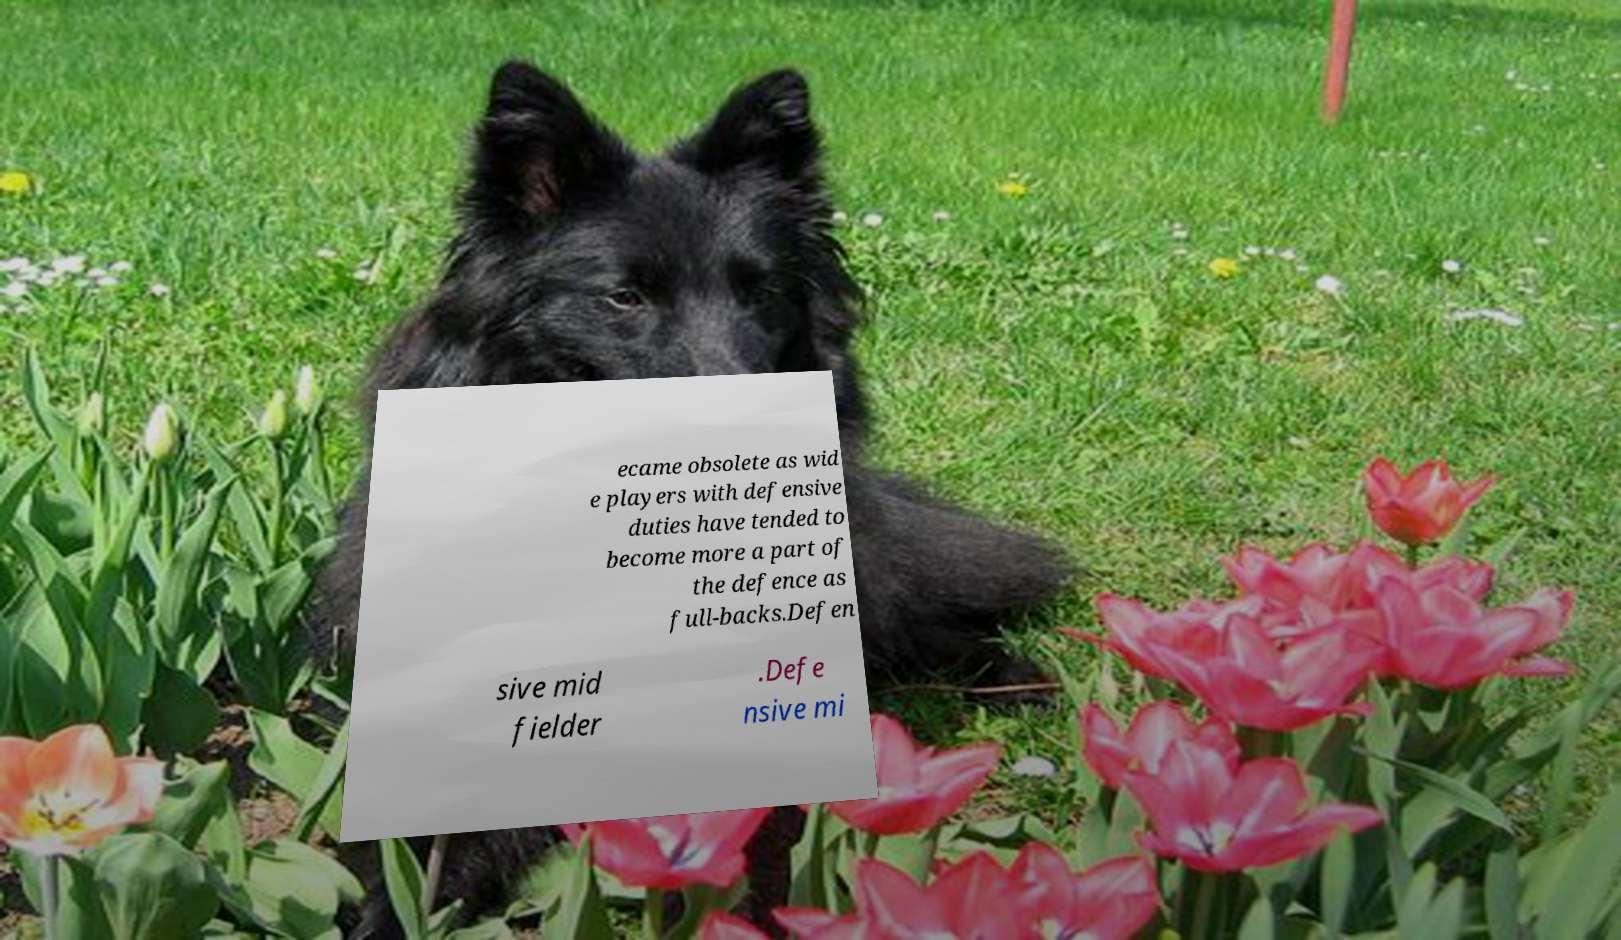Can you read and provide the text displayed in the image?This photo seems to have some interesting text. Can you extract and type it out for me? ecame obsolete as wid e players with defensive duties have tended to become more a part of the defence as full-backs.Defen sive mid fielder .Defe nsive mi 